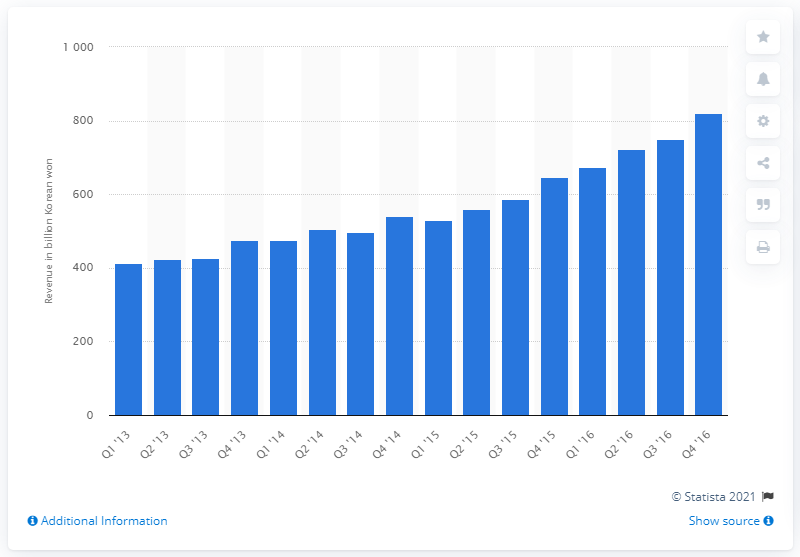List a handful of essential elements in this visual. Naver's digital advertising sales in the most recent quarter were 821.88. 